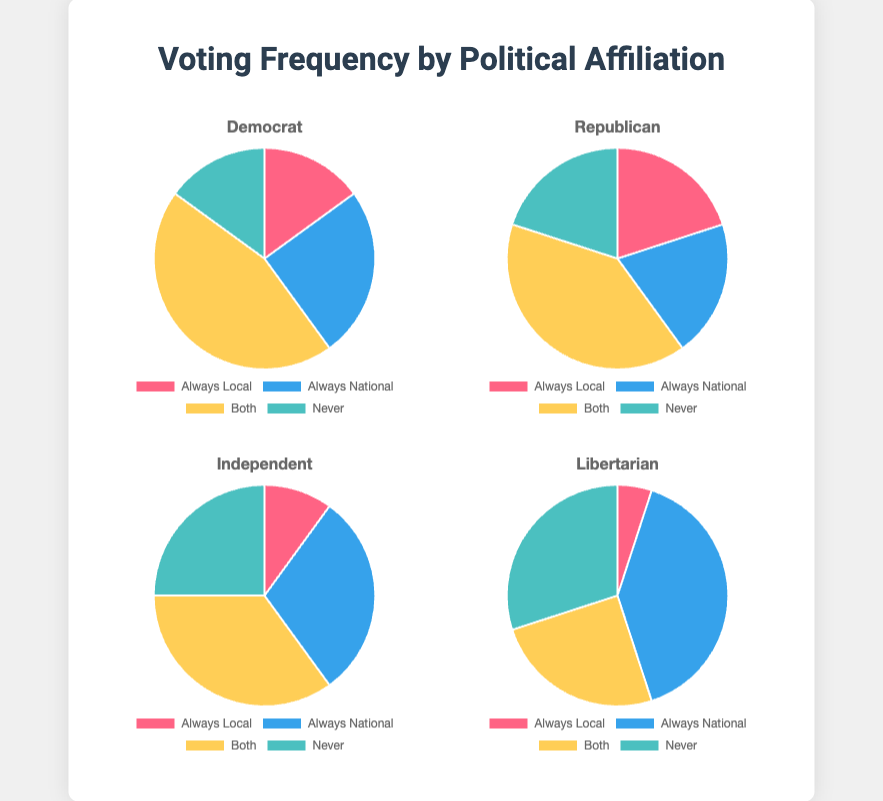Which political affiliation has the highest percentage of people who never vote in either election? Examine the "Never" category for each political affiliation. The percentages are: Democrat 15%, Republican 20%, Independent 25%, and Libertarian 30%. Libertarians have the highest percentage.
Answer: Libertarian Which group has a higher percentage of people who vote both locally and nationally, Republicans or Independents? Look at the "Both" category for both groups. Republicans have 40%, and Independents have 35%. Thus, Republicans have a higher percentage.
Answer: Republicans What is the combined percentage of Democrats who either always vote locally or never vote? Sum the percentages for "Always Local" and "Never" for Democrats. Always Local is 15%, and Never is 15%. Adding these gives 15% + 15% = 30%.
Answer: 30% Which political affiliation has the least number of people who always vote locally? Compare the "Always Local" percentages for all political affiliations: Democrat 15%, Republican 20%, Independent 10%, and Libertarian 5%. Libertarians have the least percentage.
Answer: Libertarian What is the difference in percentage between Republicans who always vote nationally and Independents who always vote nationally? Find the percentages for "Always National": Republicans have 20% and Independents have 30%. The difference is 30% - 20% = 10%.
Answer: 10% Which political group has the largest percentage of people who always vote nationally, and what is that percentage? Compare the "Always National" category across all groups. The values are: Democrat 25%, Republican 20%, Independent 30%, Libertarian 40%. Libertarians have the largest percentage at 40%.
Answer: Libertarian, 40% If we group together those who either vote both locally and nationally or never vote, which political affiliation has the highest combined percentage? For each affiliation, sum the "Both" and "Never" categories: 
Democrat: 45% + 15% = 60%,
Republican: 40% + 20% = 60%,
Independent: 35% + 25% = 60%,
Libertarian: 25% + 30% = 55%.
Democrats, Republicans, and Independents all have the highest combined percentage at 60%.
Answer: Democrat, Republican, Independent What is the combined percentage of Independents who either always vote nationally or never vote? Add the percentages for Independents in the "Always National" and "Never" categories: 30% + 25% = 55%.
Answer: 55% Which color represents the "Always Local" category in the dataset? The "Always Local" category is represented by the first color in the color list, which is mentioned earlier in the code portion as '#FF6384'. This translates to the color pink or red.
Answer: Red/Pink 